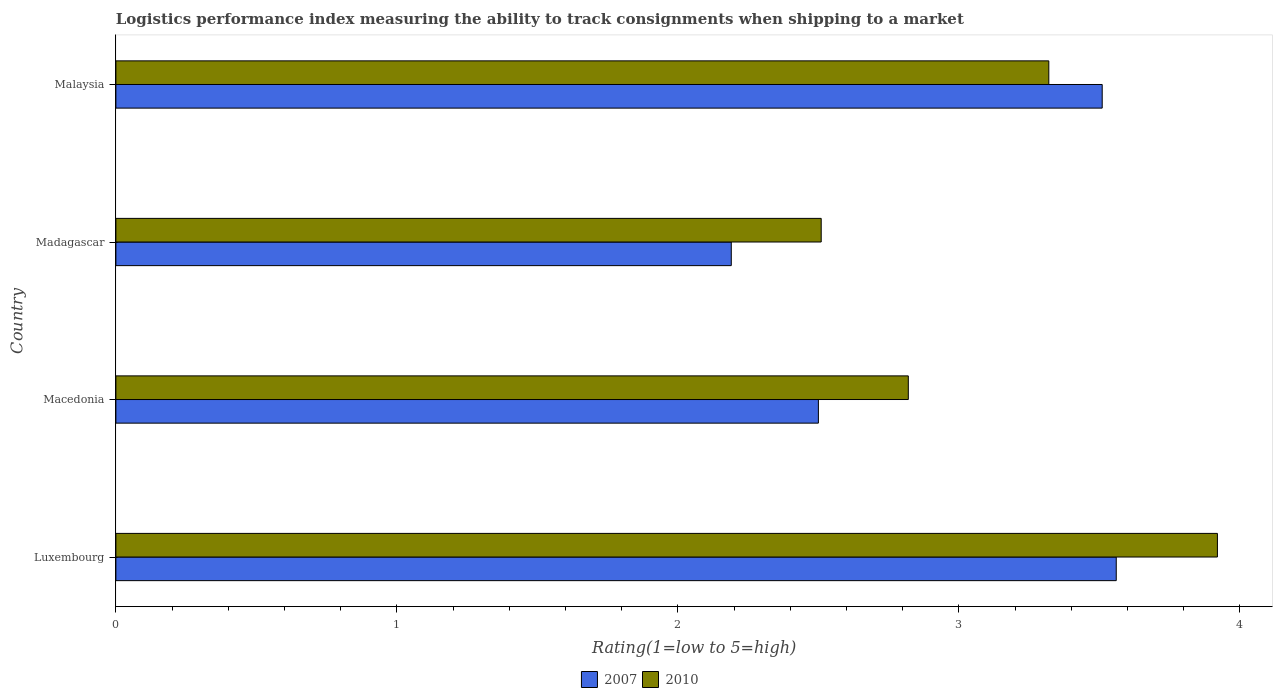How many groups of bars are there?
Ensure brevity in your answer.  4. Are the number of bars on each tick of the Y-axis equal?
Ensure brevity in your answer.  Yes. How many bars are there on the 2nd tick from the bottom?
Your answer should be very brief. 2. What is the label of the 3rd group of bars from the top?
Provide a succinct answer. Macedonia. What is the Logistic performance index in 2007 in Macedonia?
Keep it short and to the point. 2.5. Across all countries, what is the maximum Logistic performance index in 2010?
Give a very brief answer. 3.92. Across all countries, what is the minimum Logistic performance index in 2007?
Provide a short and direct response. 2.19. In which country was the Logistic performance index in 2007 maximum?
Make the answer very short. Luxembourg. In which country was the Logistic performance index in 2007 minimum?
Ensure brevity in your answer.  Madagascar. What is the total Logistic performance index in 2010 in the graph?
Make the answer very short. 12.57. What is the difference between the Logistic performance index in 2007 in Macedonia and that in Malaysia?
Offer a very short reply. -1.01. What is the difference between the Logistic performance index in 2007 in Macedonia and the Logistic performance index in 2010 in Malaysia?
Make the answer very short. -0.82. What is the average Logistic performance index in 2010 per country?
Make the answer very short. 3.14. What is the difference between the Logistic performance index in 2010 and Logistic performance index in 2007 in Madagascar?
Provide a succinct answer. 0.32. What is the ratio of the Logistic performance index in 2007 in Macedonia to that in Malaysia?
Offer a very short reply. 0.71. What is the difference between the highest and the second highest Logistic performance index in 2010?
Provide a succinct answer. 0.6. What is the difference between the highest and the lowest Logistic performance index in 2007?
Your response must be concise. 1.37. In how many countries, is the Logistic performance index in 2007 greater than the average Logistic performance index in 2007 taken over all countries?
Make the answer very short. 2. Is the sum of the Logistic performance index in 2010 in Luxembourg and Macedonia greater than the maximum Logistic performance index in 2007 across all countries?
Your answer should be very brief. Yes. What does the 2nd bar from the bottom in Madagascar represents?
Keep it short and to the point. 2010. Are the values on the major ticks of X-axis written in scientific E-notation?
Give a very brief answer. No. Does the graph contain grids?
Offer a terse response. No. Where does the legend appear in the graph?
Give a very brief answer. Bottom center. What is the title of the graph?
Provide a short and direct response. Logistics performance index measuring the ability to track consignments when shipping to a market. What is the label or title of the X-axis?
Give a very brief answer. Rating(1=low to 5=high). What is the Rating(1=low to 5=high) of 2007 in Luxembourg?
Make the answer very short. 3.56. What is the Rating(1=low to 5=high) in 2010 in Luxembourg?
Offer a terse response. 3.92. What is the Rating(1=low to 5=high) in 2010 in Macedonia?
Your answer should be very brief. 2.82. What is the Rating(1=low to 5=high) of 2007 in Madagascar?
Make the answer very short. 2.19. What is the Rating(1=low to 5=high) in 2010 in Madagascar?
Offer a terse response. 2.51. What is the Rating(1=low to 5=high) in 2007 in Malaysia?
Offer a very short reply. 3.51. What is the Rating(1=low to 5=high) in 2010 in Malaysia?
Your response must be concise. 3.32. Across all countries, what is the maximum Rating(1=low to 5=high) of 2007?
Give a very brief answer. 3.56. Across all countries, what is the maximum Rating(1=low to 5=high) of 2010?
Your response must be concise. 3.92. Across all countries, what is the minimum Rating(1=low to 5=high) of 2007?
Offer a very short reply. 2.19. Across all countries, what is the minimum Rating(1=low to 5=high) in 2010?
Provide a succinct answer. 2.51. What is the total Rating(1=low to 5=high) in 2007 in the graph?
Your response must be concise. 11.76. What is the total Rating(1=low to 5=high) of 2010 in the graph?
Ensure brevity in your answer.  12.57. What is the difference between the Rating(1=low to 5=high) in 2007 in Luxembourg and that in Macedonia?
Offer a terse response. 1.06. What is the difference between the Rating(1=low to 5=high) in 2007 in Luxembourg and that in Madagascar?
Provide a short and direct response. 1.37. What is the difference between the Rating(1=low to 5=high) of 2010 in Luxembourg and that in Madagascar?
Keep it short and to the point. 1.41. What is the difference between the Rating(1=low to 5=high) in 2010 in Luxembourg and that in Malaysia?
Offer a terse response. 0.6. What is the difference between the Rating(1=low to 5=high) in 2007 in Macedonia and that in Madagascar?
Your response must be concise. 0.31. What is the difference between the Rating(1=low to 5=high) in 2010 in Macedonia and that in Madagascar?
Your response must be concise. 0.31. What is the difference between the Rating(1=low to 5=high) of 2007 in Macedonia and that in Malaysia?
Offer a terse response. -1.01. What is the difference between the Rating(1=low to 5=high) in 2010 in Macedonia and that in Malaysia?
Provide a succinct answer. -0.5. What is the difference between the Rating(1=low to 5=high) in 2007 in Madagascar and that in Malaysia?
Offer a very short reply. -1.32. What is the difference between the Rating(1=low to 5=high) of 2010 in Madagascar and that in Malaysia?
Your response must be concise. -0.81. What is the difference between the Rating(1=low to 5=high) of 2007 in Luxembourg and the Rating(1=low to 5=high) of 2010 in Macedonia?
Ensure brevity in your answer.  0.74. What is the difference between the Rating(1=low to 5=high) of 2007 in Luxembourg and the Rating(1=low to 5=high) of 2010 in Malaysia?
Your answer should be very brief. 0.24. What is the difference between the Rating(1=low to 5=high) of 2007 in Macedonia and the Rating(1=low to 5=high) of 2010 in Madagascar?
Your answer should be compact. -0.01. What is the difference between the Rating(1=low to 5=high) of 2007 in Macedonia and the Rating(1=low to 5=high) of 2010 in Malaysia?
Give a very brief answer. -0.82. What is the difference between the Rating(1=low to 5=high) in 2007 in Madagascar and the Rating(1=low to 5=high) in 2010 in Malaysia?
Offer a very short reply. -1.13. What is the average Rating(1=low to 5=high) of 2007 per country?
Your answer should be compact. 2.94. What is the average Rating(1=low to 5=high) in 2010 per country?
Your answer should be compact. 3.14. What is the difference between the Rating(1=low to 5=high) of 2007 and Rating(1=low to 5=high) of 2010 in Luxembourg?
Keep it short and to the point. -0.36. What is the difference between the Rating(1=low to 5=high) of 2007 and Rating(1=low to 5=high) of 2010 in Macedonia?
Your answer should be compact. -0.32. What is the difference between the Rating(1=low to 5=high) in 2007 and Rating(1=low to 5=high) in 2010 in Madagascar?
Provide a short and direct response. -0.32. What is the difference between the Rating(1=low to 5=high) in 2007 and Rating(1=low to 5=high) in 2010 in Malaysia?
Give a very brief answer. 0.19. What is the ratio of the Rating(1=low to 5=high) in 2007 in Luxembourg to that in Macedonia?
Offer a very short reply. 1.42. What is the ratio of the Rating(1=low to 5=high) of 2010 in Luxembourg to that in Macedonia?
Keep it short and to the point. 1.39. What is the ratio of the Rating(1=low to 5=high) of 2007 in Luxembourg to that in Madagascar?
Your answer should be very brief. 1.63. What is the ratio of the Rating(1=low to 5=high) of 2010 in Luxembourg to that in Madagascar?
Offer a terse response. 1.56. What is the ratio of the Rating(1=low to 5=high) of 2007 in Luxembourg to that in Malaysia?
Provide a short and direct response. 1.01. What is the ratio of the Rating(1=low to 5=high) of 2010 in Luxembourg to that in Malaysia?
Your answer should be very brief. 1.18. What is the ratio of the Rating(1=low to 5=high) of 2007 in Macedonia to that in Madagascar?
Make the answer very short. 1.14. What is the ratio of the Rating(1=low to 5=high) in 2010 in Macedonia to that in Madagascar?
Give a very brief answer. 1.12. What is the ratio of the Rating(1=low to 5=high) of 2007 in Macedonia to that in Malaysia?
Give a very brief answer. 0.71. What is the ratio of the Rating(1=low to 5=high) in 2010 in Macedonia to that in Malaysia?
Your answer should be very brief. 0.85. What is the ratio of the Rating(1=low to 5=high) in 2007 in Madagascar to that in Malaysia?
Make the answer very short. 0.62. What is the ratio of the Rating(1=low to 5=high) of 2010 in Madagascar to that in Malaysia?
Your answer should be very brief. 0.76. What is the difference between the highest and the second highest Rating(1=low to 5=high) of 2010?
Ensure brevity in your answer.  0.6. What is the difference between the highest and the lowest Rating(1=low to 5=high) of 2007?
Offer a terse response. 1.37. What is the difference between the highest and the lowest Rating(1=low to 5=high) of 2010?
Keep it short and to the point. 1.41. 